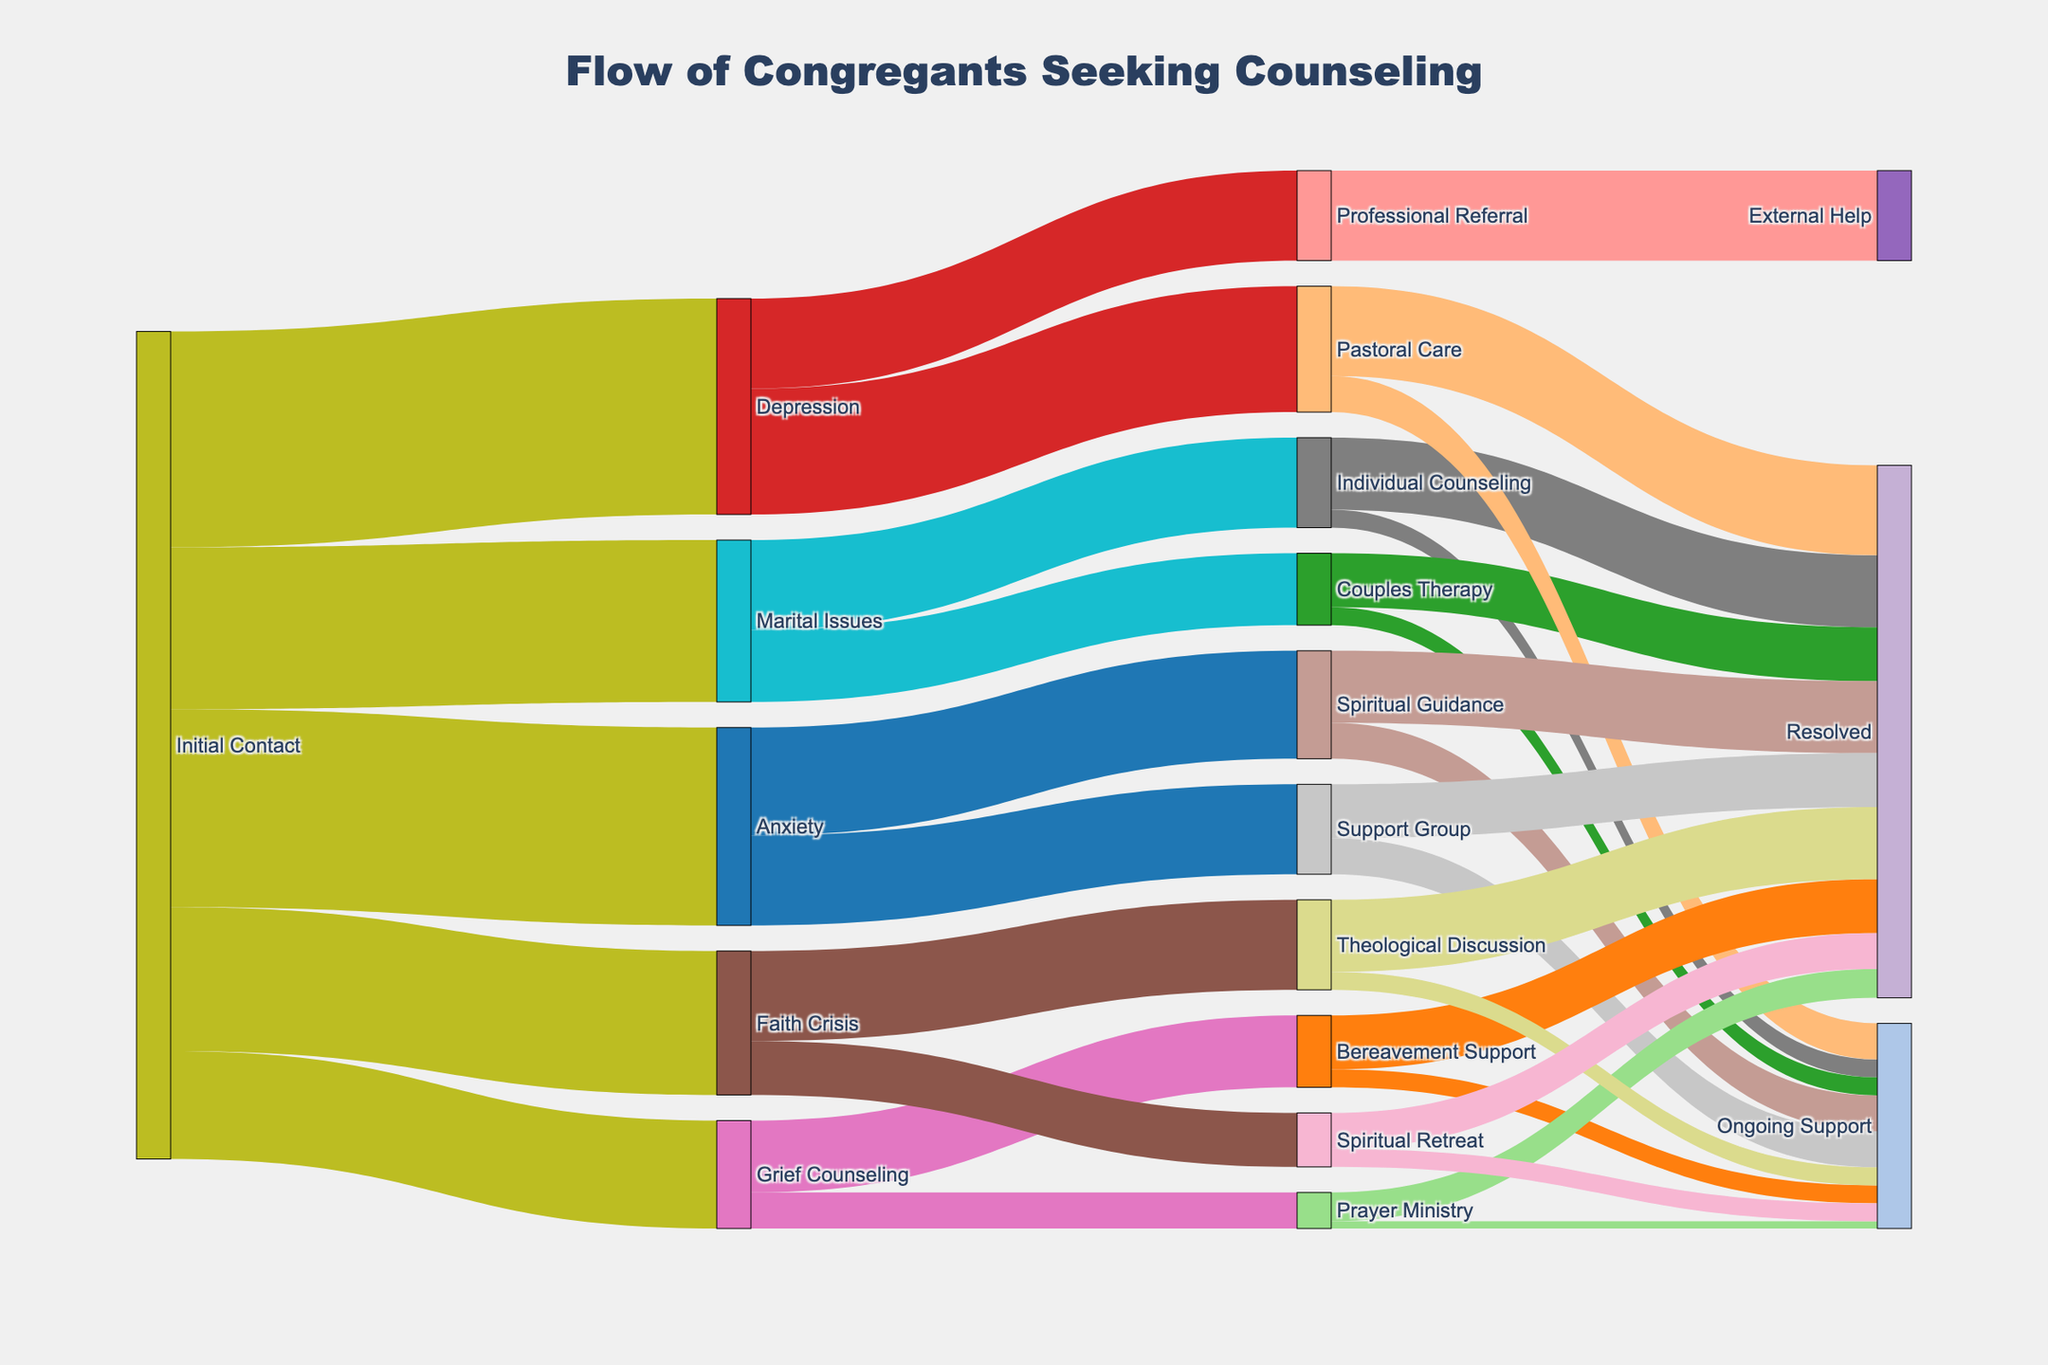What's the main title of the figure? The main title is prominently displayed at the top of the figure and encapsulates the overall flow of the data. By looking at the top of the figure, you can read the title.
Answer: Flow of Congregants Seeking Counseling Which issue type has the highest number of congregants at initial contact? Assess the value labels associated with each issue type stemming from "Initial Contact." Identify the highest value among them.
Answer: Depression What is the combined total of congregants dealing with anxiety who proceed to "Spiritual Guidance" and "Support Group"? Identify the flow values from "Anxiety" to "Spiritual Guidance" and "Support Group," then sum them up: 30 (Spiritual Guidance) + 25 (Support Group).
Answer: 55 Is individual counseling more likely to result in resolved or ongoing support cases? Compare the flow values from "Individual Counseling" to "Resolved" and "Ongoing Support." "Resolved" has a flow of 20, and "Ongoing Support" has 5.
Answer: Resolved What are the final resolutions possible for congregants who initially seek grief counseling? Observe the pathways from "Grief Counseling" to its next targets and further observe the final nodes these paths connect to. The flows are from "Bereavement Support" to "Resolved" and "Ongoing Support," as well as from "Prayer Ministry" to "Resolved" and "Ongoing Support."
Answer: Resolved, Ongoing Support Which resolution category has the lowest count through the faith crisis path, and what is that count? Trace the paths from "Faith Crisis" to their resolutions and find the smallest flow value among them. The two resolution paths are "Theological Discussion" with "Resolved" (20) and "Ongoing Support" (5), and "Spiritual Retreat" with "Resolved" (10) and "Ongoing Support" (5). The smallest value is for "Ongoing Support" from "Faith Crisis".
Answer: Ongoing Support, 5 How does the number of congregants in couples therapy who achieve resolution compare to those in individual counseling who achieve resolution? Look at the flows from "Couples Therapy" to "Resolved" (15) and from "Individual Counseling" to "Resolved" (20). Compare the values.
Answer: Individual Counseling > Couples Therapy From the "Depression" group, which resolution category has the highest number of congregants? Trace the flows from "Depression" to its final resolution categories: "Pastoral Care" (Resolved 25, Ongoing Support 10) and "Professional Referral" (External Help 25). Compare these to find the highest.
Answer: Resolved (Pastoral Care) How many congregants are in ongoing support after seeking spiritual guidance for anxiety? Find the flow from "Spiritual Guidance" associated with "Anxiety," leading to "Ongoing Support."
Answer: 10 Why might the Sankey diagram be a useful tool in visualizing the flow of congregants through counseling processes? Sankey diagrams highlight the paths and volume of flows between stages, making it easy to track how groups transition from one state to another, emphasize bottlenecks, patterns, and the distribution of congregants. Detailed analysis shows the importance of understanding the proportional flow and pathway transitions.
Answer: It visualizes the flow and volume of transitions accurately 